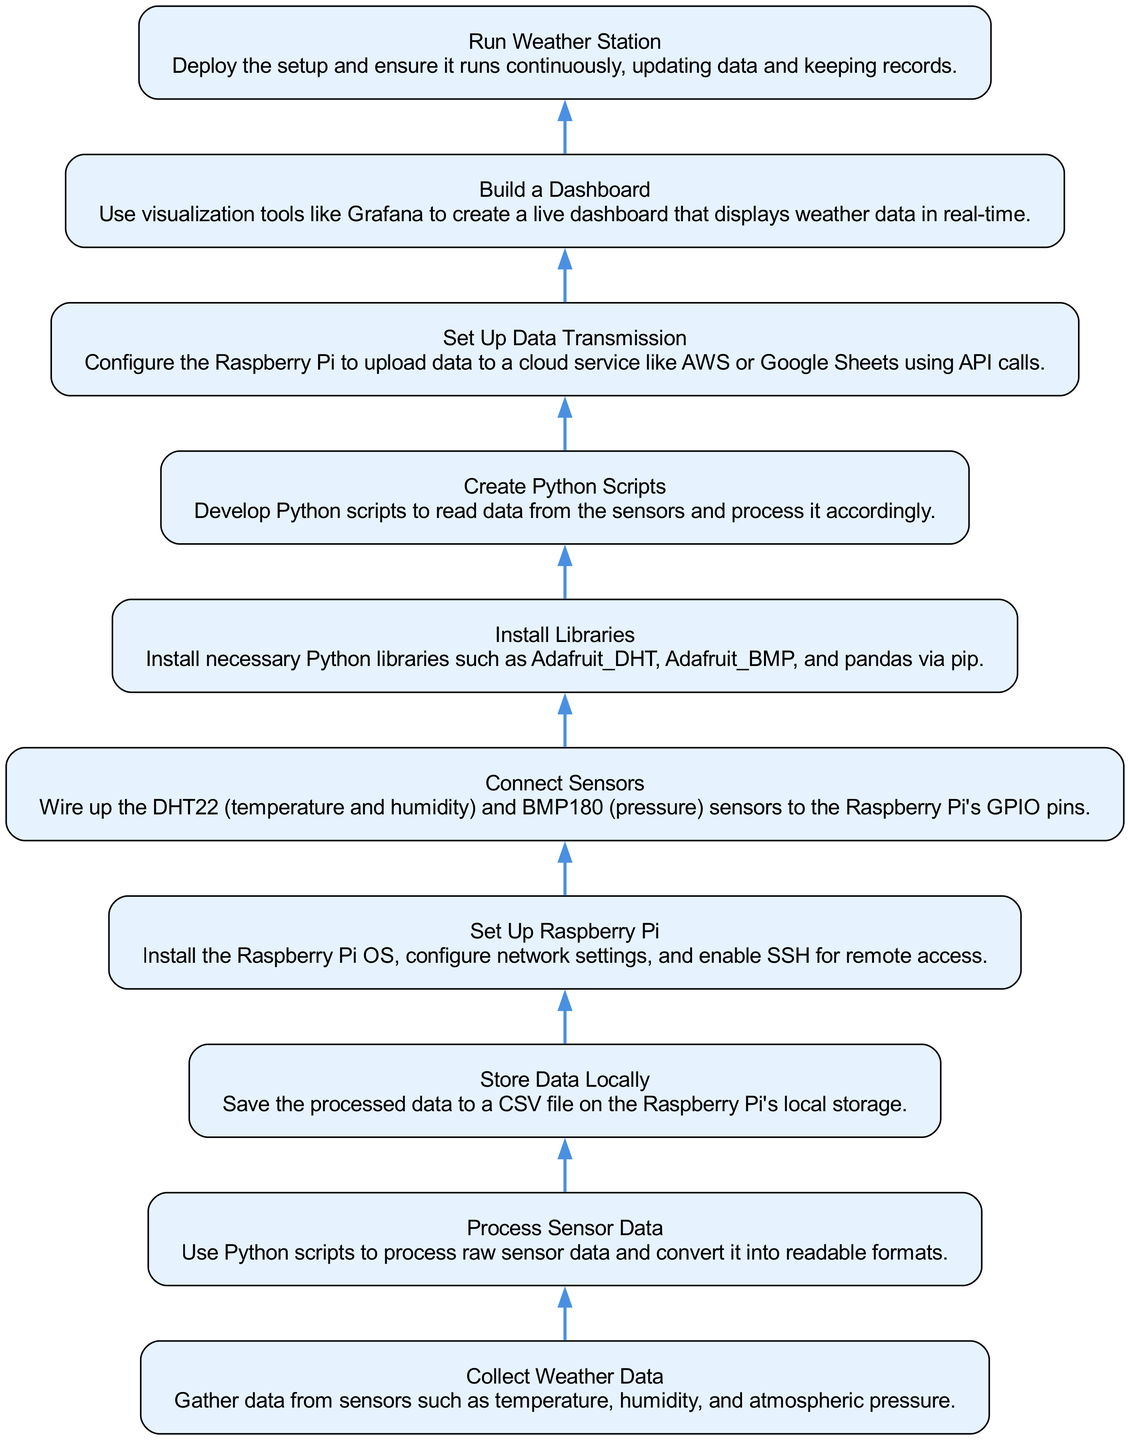What is the first step in the diagram? The diagram starts with the first node labeled "Set Up Raspberry Pi", indicating that initializing the Raspberry Pi is the first action to take.
Answer: Set Up Raspberry Pi How many sensors are mentioned in the diagram? The diagram specifies two sensors: the DHT22 and the BMP180, indicating that a total of two sensors are utilized in the weather station setup.
Answer: Two What is the last action taken in the process? The final node in the diagram is "Run Weather Station", which indicates that the ultimate goal is to deploy the setup for continuous operation.
Answer: Run Weather Station What follows the "Install Libraries" step? After the "Install Libraries" step, the next step is "Create Python Scripts", showing that you need to develop scripts after installing the necessary libraries.
Answer: Create Python Scripts What should be done after processing the sensor data? After processing the sensor data, the next action is to "Store Data Locally", indicating that the data should be saved locally to a file.
Answer: Store Data Locally How many nodes are there in total? The diagram lists a total of ten nodes, each representing a different step in building the Raspberry Pi-based weather station.
Answer: Ten Which step requires the configuration of a cloud service? The step labeled "Set Up Data Transmission" indicates that this is where you configure the Raspberry Pi to send data to a cloud service, such as AWS or Google Sheets.
Answer: Set Up Data Transmission What is the major purpose of "Build a Dashboard"? The node "Build a Dashboard" aims to create a visual representation of the weather data, allowing users to view the data in real-time through a dashboard interface.
Answer: Create a live dashboard What step directly precedes "Run Weather Station"? The step just before "Run Weather Station" is "Set Up Data Transmission", showing that you must ensure data is being transmitted correctly before deploying the station.
Answer: Set Up Data Transmission 